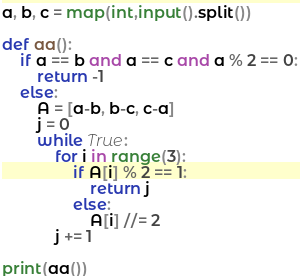Convert code to text. <code><loc_0><loc_0><loc_500><loc_500><_Python_>a, b, c = map(int,input().split())

def aa():
    if a == b and a == c and a % 2 == 0:
        return -1
    else:
        A = [a-b, b-c, c-a]
        j = 0
        while True:
            for i in range(3):
                if A[i] % 2 == 1:
                    return j
                else:
                    A[i] //= 2
            j += 1

print(aa())</code> 